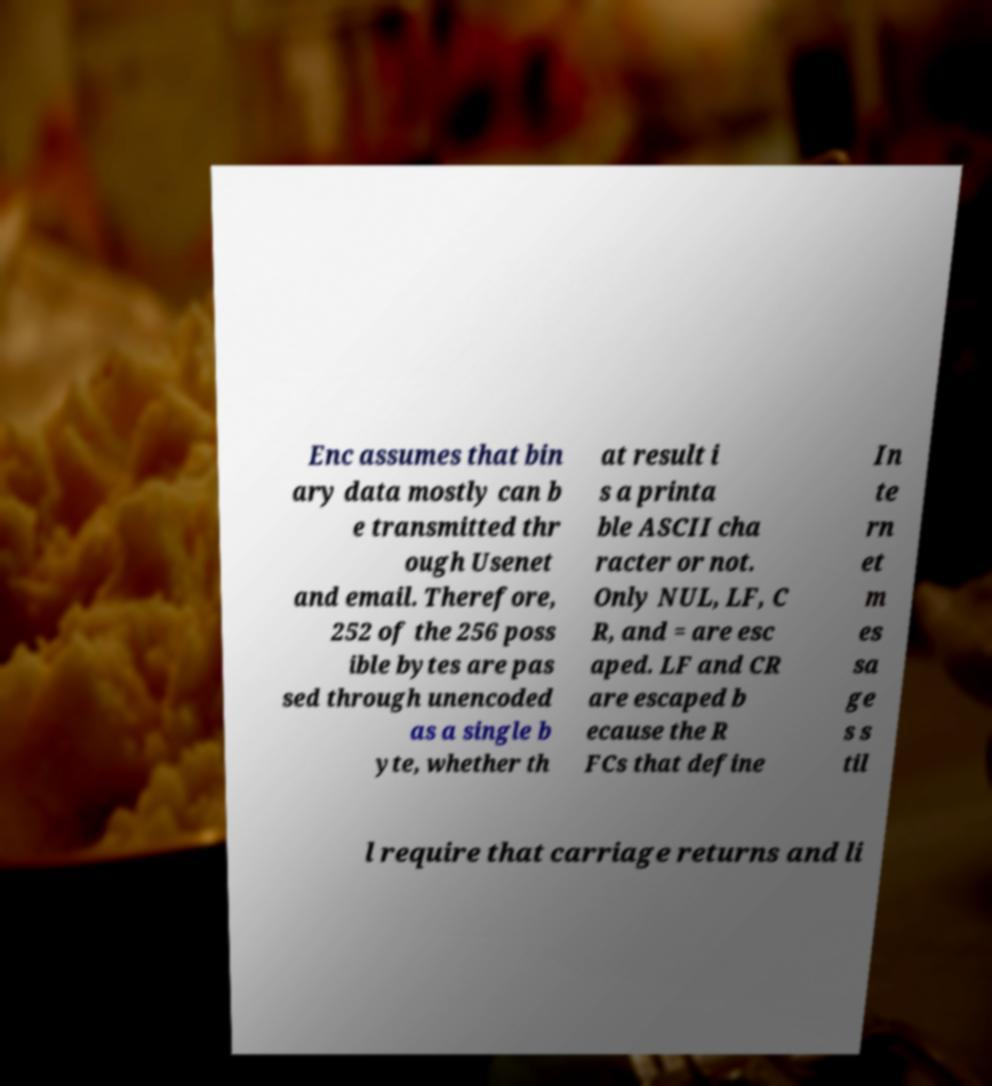There's text embedded in this image that I need extracted. Can you transcribe it verbatim? Enc assumes that bin ary data mostly can b e transmitted thr ough Usenet and email. Therefore, 252 of the 256 poss ible bytes are pas sed through unencoded as a single b yte, whether th at result i s a printa ble ASCII cha racter or not. Only NUL, LF, C R, and = are esc aped. LF and CR are escaped b ecause the R FCs that define In te rn et m es sa ge s s til l require that carriage returns and li 